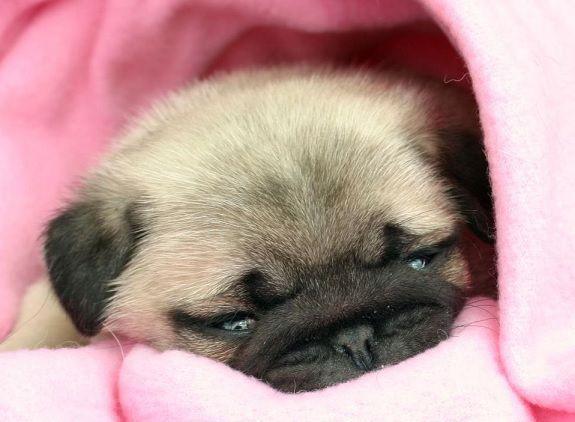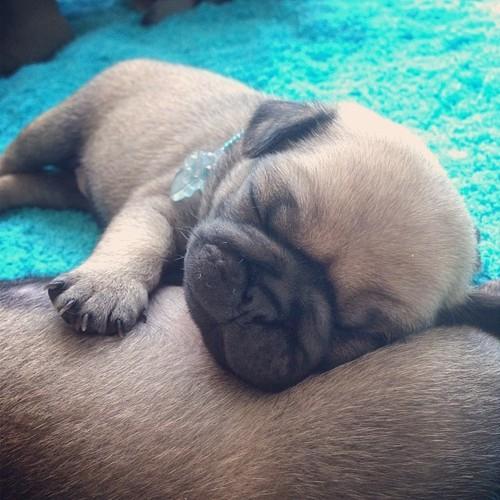The first image is the image on the left, the second image is the image on the right. Considering the images on both sides, is "One image shows a pug puppy with its head resting on the fur of a real animal, and the other image shows one real pug with its head resting on something plush." valid? Answer yes or no. Yes. The first image is the image on the left, the second image is the image on the right. Considering the images on both sides, is "There is exactly 1 puppy lying down in the image on the left." valid? Answer yes or no. Yes. 